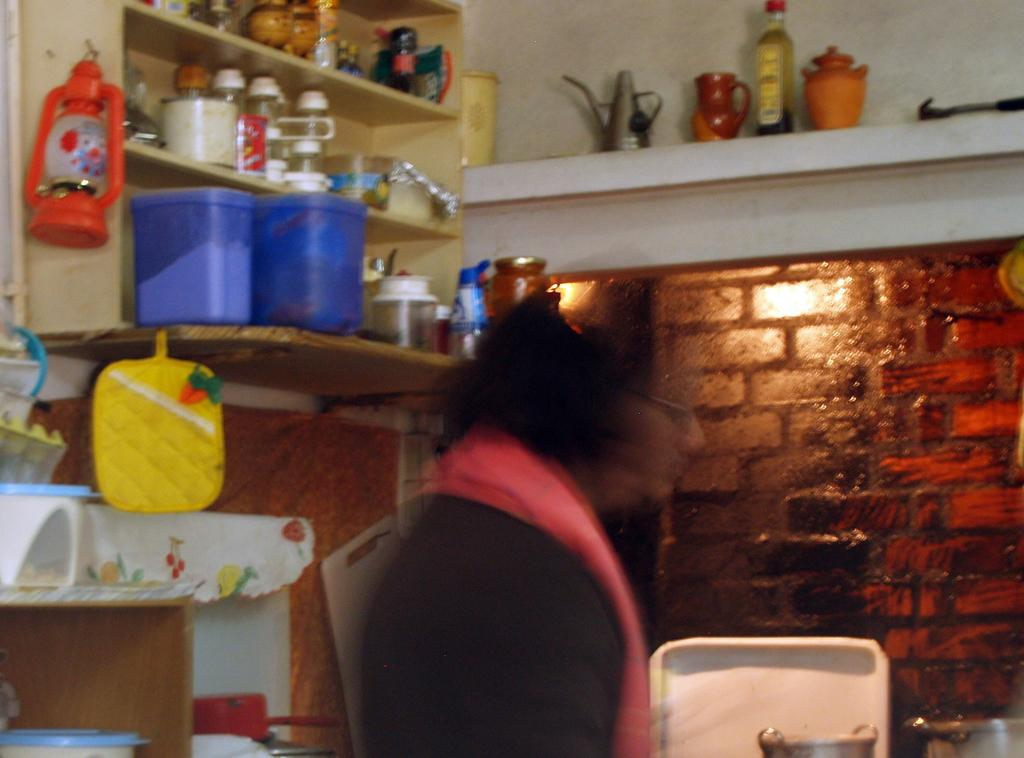Who is the main subject in the image? There is a woman in the middle of the image. What can be seen on the left side of the image? There is a shelf on the left side of the image. What is on the shelf? There are items placed on the shelf. What is visible in the background of the image? There is a wall in the background of the image. What type of shoes is the woman wearing in the image? The image does not show the woman's shoes, so it cannot be determined from the image. Can you tell me how many basketballs are on the shelf in the image? There are no basketballs present in the image; the shelf contains other items. 